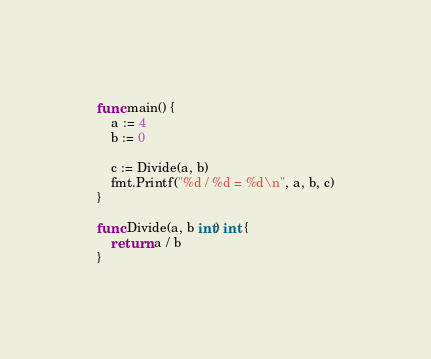<code> <loc_0><loc_0><loc_500><loc_500><_Go_>
func main() {
	a := 4
	b := 0

	c := Divide(a, b)
	fmt.Printf("%d / %d = %d\n", a, b, c)
}

func Divide(a, b int) int {
	return a / b
}
</code> 